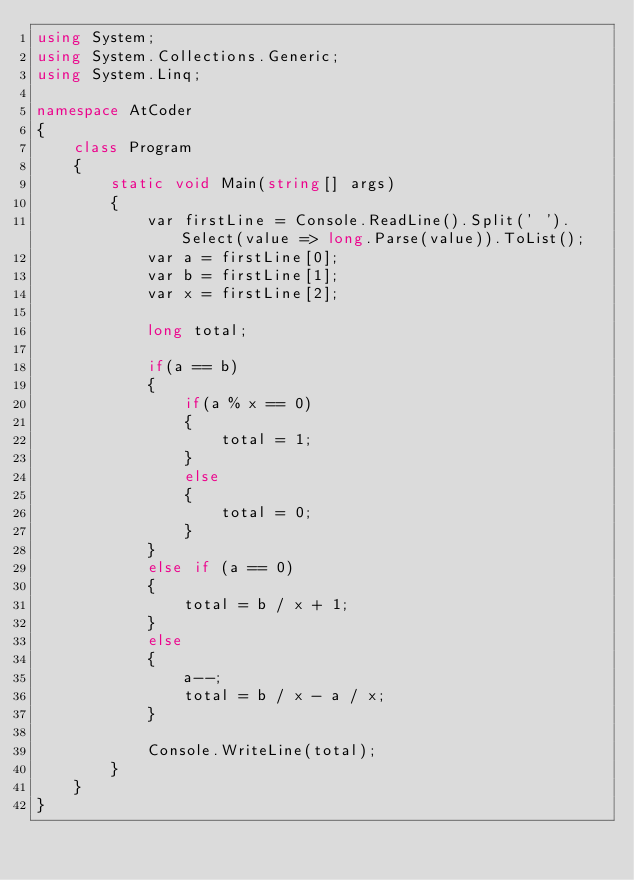Convert code to text. <code><loc_0><loc_0><loc_500><loc_500><_C#_>using System;
using System.Collections.Generic;
using System.Linq;

namespace AtCoder
{
	class Program
	{
		static void Main(string[] args)
		{
			var firstLine = Console.ReadLine().Split(' ').Select(value => long.Parse(value)).ToList();
			var a = firstLine[0];
			var b = firstLine[1];
			var x = firstLine[2];

			long total;

			if(a == b)
			{
				if(a % x == 0)
				{
					total = 1;
				}
				else
				{
					total = 0;
				}
			}
			else if (a == 0)
			{
				total = b / x + 1;
			}
			else
			{
				a--;
				total = b / x - a / x;
			}

			Console.WriteLine(total);
		}
	}
}
</code> 